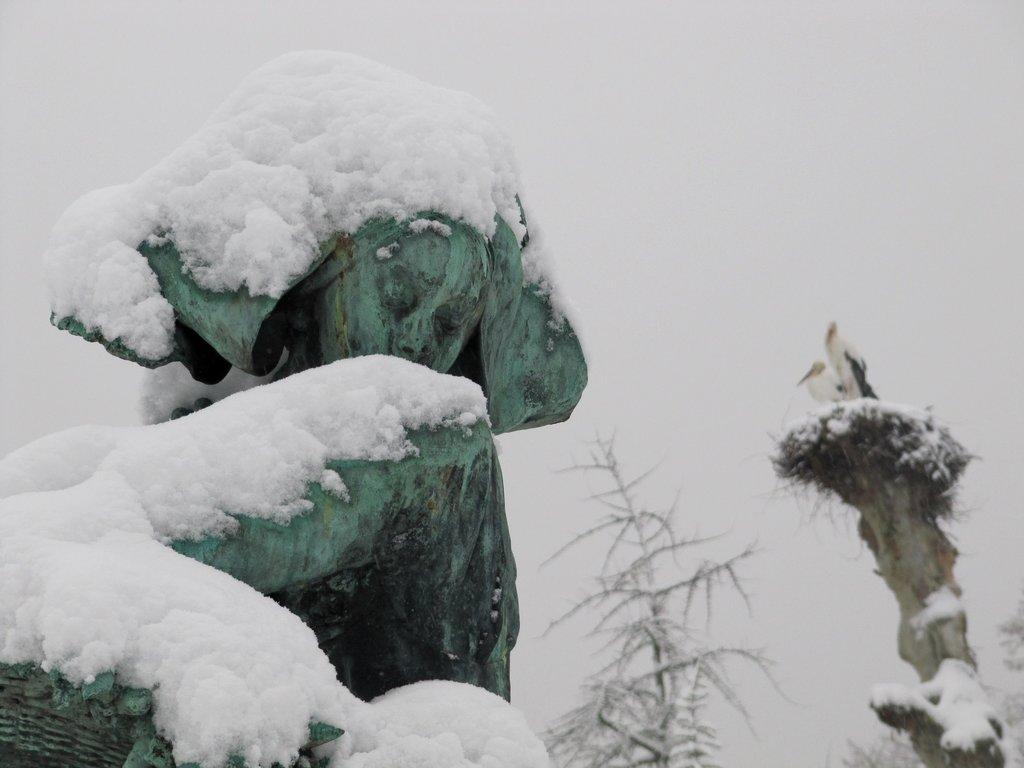What is covered in snow on the left side of the image? There is snow on something on the left side of the image, but the specific object is not mentioned. What can be seen on the right side of the image? There are birds visible on the right side of the image. What type of behavior can be observed in the ring on the left side of the image? There is no ring present in the image; it mentions snow on something on the left side. How does the crook affect the birds on the right side of the image? There is no crook present in the image; it only mentions birds on the right side. 